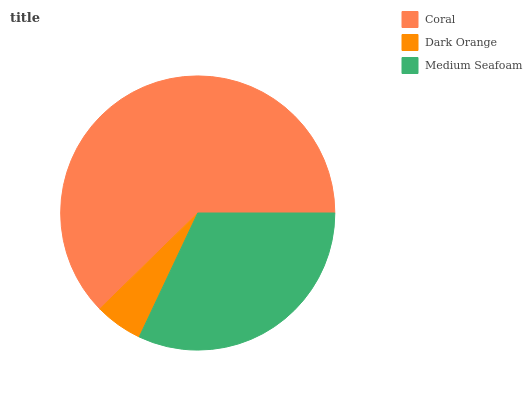Is Dark Orange the minimum?
Answer yes or no. Yes. Is Coral the maximum?
Answer yes or no. Yes. Is Medium Seafoam the minimum?
Answer yes or no. No. Is Medium Seafoam the maximum?
Answer yes or no. No. Is Medium Seafoam greater than Dark Orange?
Answer yes or no. Yes. Is Dark Orange less than Medium Seafoam?
Answer yes or no. Yes. Is Dark Orange greater than Medium Seafoam?
Answer yes or no. No. Is Medium Seafoam less than Dark Orange?
Answer yes or no. No. Is Medium Seafoam the high median?
Answer yes or no. Yes. Is Medium Seafoam the low median?
Answer yes or no. Yes. Is Dark Orange the high median?
Answer yes or no. No. Is Dark Orange the low median?
Answer yes or no. No. 